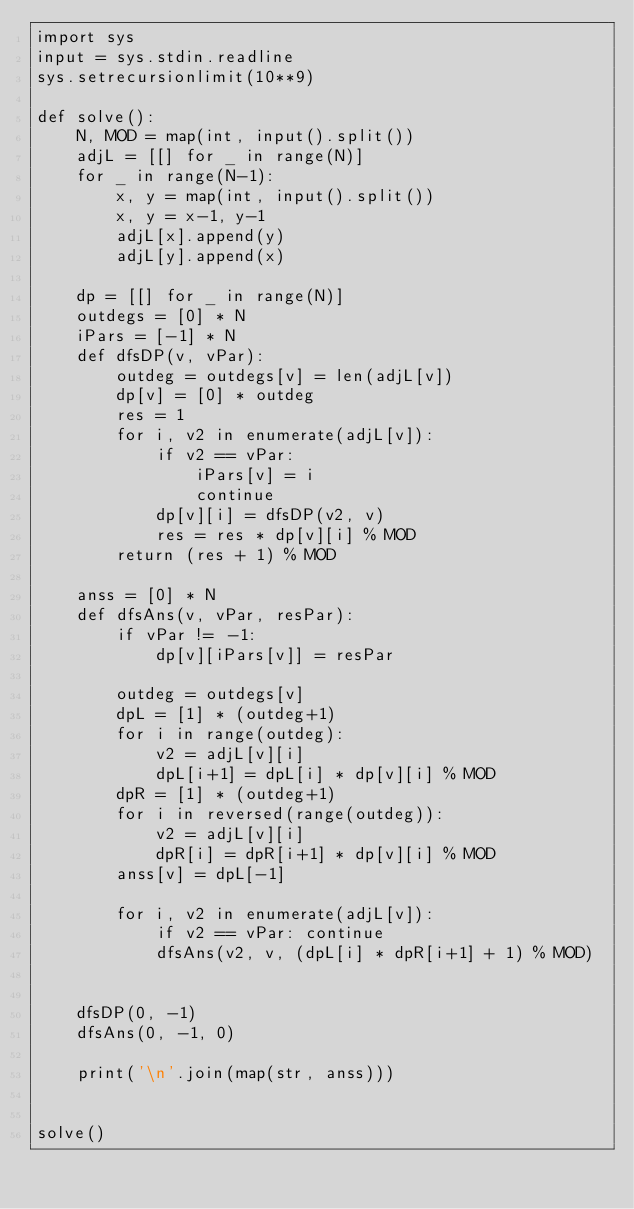Convert code to text. <code><loc_0><loc_0><loc_500><loc_500><_Python_>import sys
input = sys.stdin.readline
sys.setrecursionlimit(10**9)

def solve():
    N, MOD = map(int, input().split())
    adjL = [[] for _ in range(N)]
    for _ in range(N-1):
        x, y = map(int, input().split())
        x, y = x-1, y-1
        adjL[x].append(y)
        adjL[y].append(x)

    dp = [[] for _ in range(N)]
    outdegs = [0] * N
    iPars = [-1] * N
    def dfsDP(v, vPar):
        outdeg = outdegs[v] = len(adjL[v])
        dp[v] = [0] * outdeg
        res = 1
        for i, v2 in enumerate(adjL[v]):
            if v2 == vPar:
                iPars[v] = i
                continue
            dp[v][i] = dfsDP(v2, v)
            res = res * dp[v][i] % MOD
        return (res + 1) % MOD

    anss = [0] * N
    def dfsAns(v, vPar, resPar):
        if vPar != -1:
            dp[v][iPars[v]] = resPar

        outdeg = outdegs[v]
        dpL = [1] * (outdeg+1)
        for i in range(outdeg):
            v2 = adjL[v][i]
            dpL[i+1] = dpL[i] * dp[v][i] % MOD
        dpR = [1] * (outdeg+1)
        for i in reversed(range(outdeg)):
            v2 = adjL[v][i]
            dpR[i] = dpR[i+1] * dp[v][i] % MOD
        anss[v] = dpL[-1]

        for i, v2 in enumerate(adjL[v]):
            if v2 == vPar: continue
            dfsAns(v2, v, (dpL[i] * dpR[i+1] + 1) % MOD)


    dfsDP(0, -1)
    dfsAns(0, -1, 0)

    print('\n'.join(map(str, anss)))


solve()
</code> 